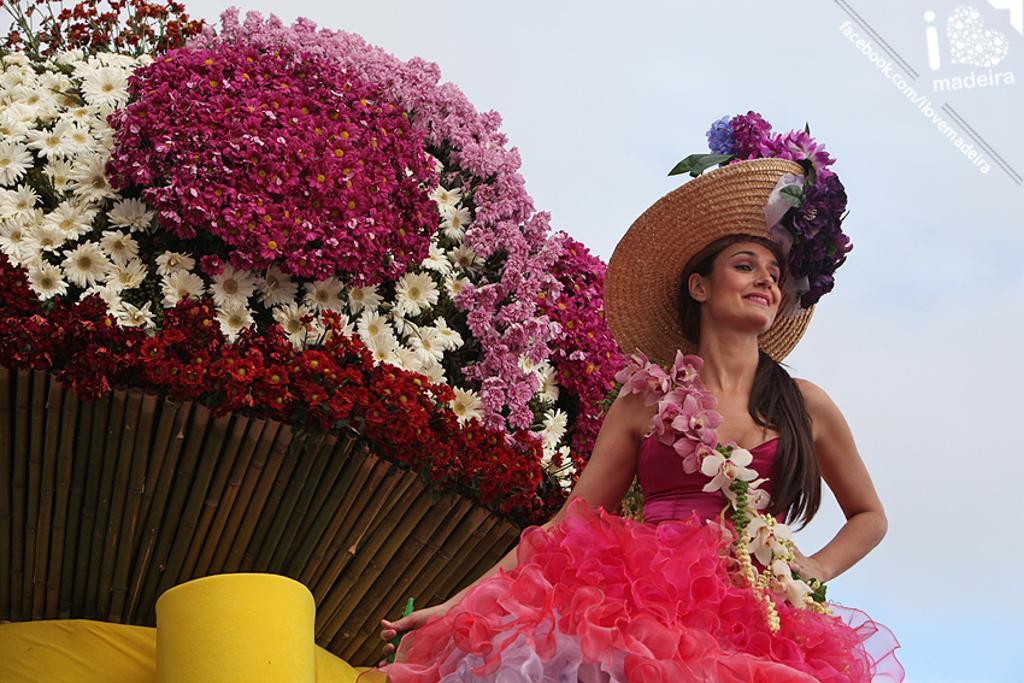Please provide a concise description of this image. In this picture we can see a woman and in the background we can see flowers. 